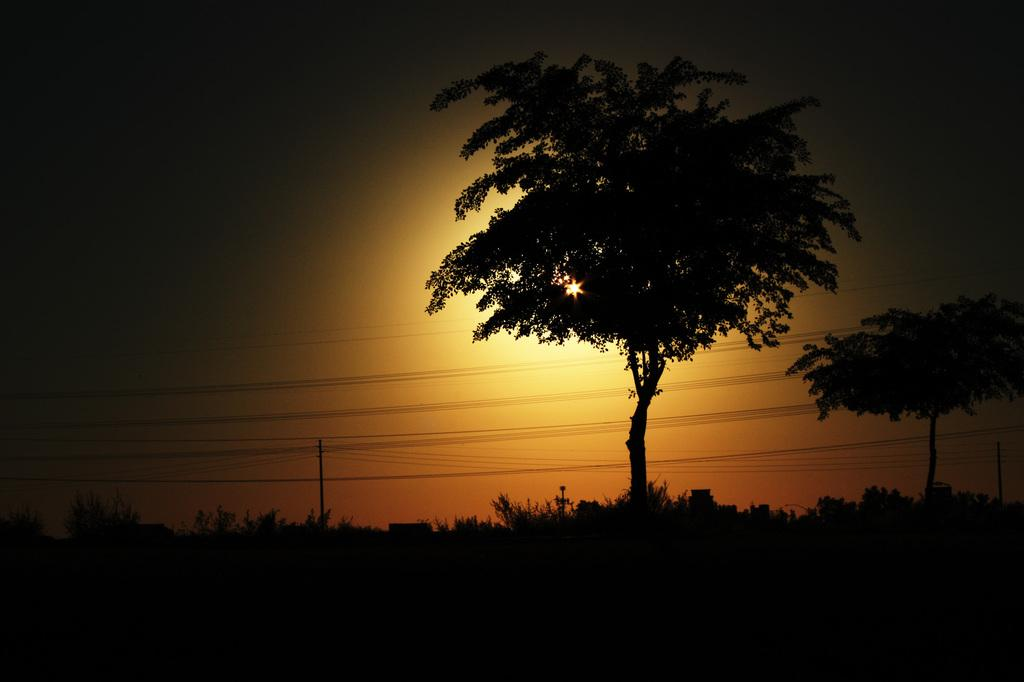What type of natural elements can be seen in the image? There are trees in the image. What man-made structures are present in the image? There are poles and wires in the image. What is visible in the background of the image? The sunset and the sky are visible in the background of the image. What type of watch is being polished in the image? There is no watch present in the image. Can you describe the boot that is being worn by the person in the image? There is no person or boot present in the image. 